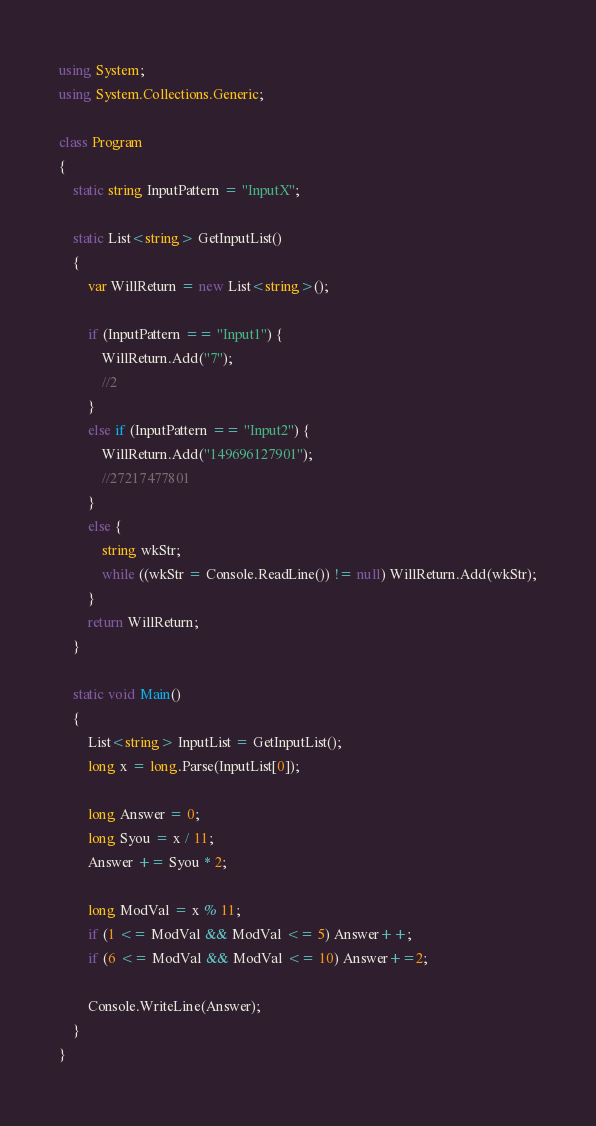Convert code to text. <code><loc_0><loc_0><loc_500><loc_500><_C#_>using System;
using System.Collections.Generic;

class Program
{
    static string InputPattern = "InputX";

    static List<string> GetInputList()
    {
        var WillReturn = new List<string>();

        if (InputPattern == "Input1") {
            WillReturn.Add("7");
            //2
        }
        else if (InputPattern == "Input2") {
            WillReturn.Add("149696127901");
            //27217477801
        }
        else {
            string wkStr;
            while ((wkStr = Console.ReadLine()) != null) WillReturn.Add(wkStr);
        }
        return WillReturn;
    }

    static void Main()
    {
        List<string> InputList = GetInputList();
        long x = long.Parse(InputList[0]);

        long Answer = 0;
        long Syou = x / 11;
        Answer += Syou * 2;

        long ModVal = x % 11;
        if (1 <= ModVal && ModVal <= 5) Answer++;
        if (6 <= ModVal && ModVal <= 10) Answer+=2;

        Console.WriteLine(Answer);
    }   
}
</code> 